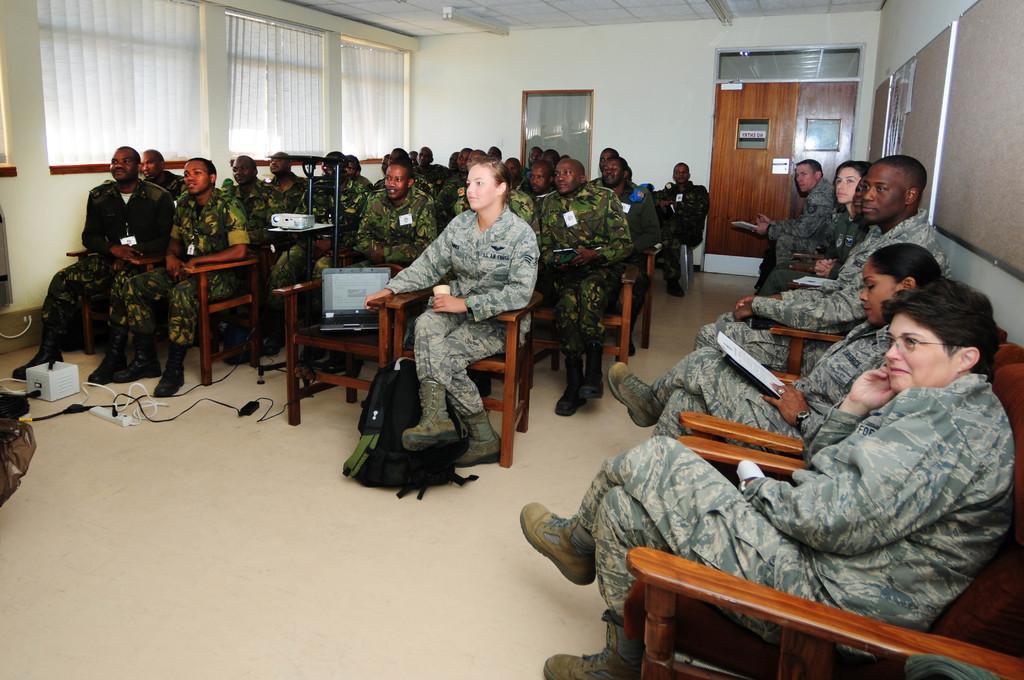How would you summarize this image in a sentence or two? In this picture of a group of people sitting on the chair and door on the right 